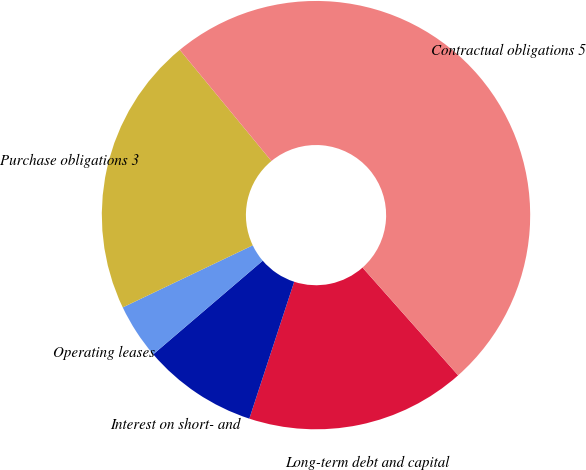Convert chart. <chart><loc_0><loc_0><loc_500><loc_500><pie_chart><fcel>Long-term debt and capital<fcel>Interest on short- and<fcel>Operating leases<fcel>Purchase obligations 3<fcel>Contractual obligations 5<nl><fcel>16.59%<fcel>8.7%<fcel>4.17%<fcel>21.12%<fcel>49.42%<nl></chart> 